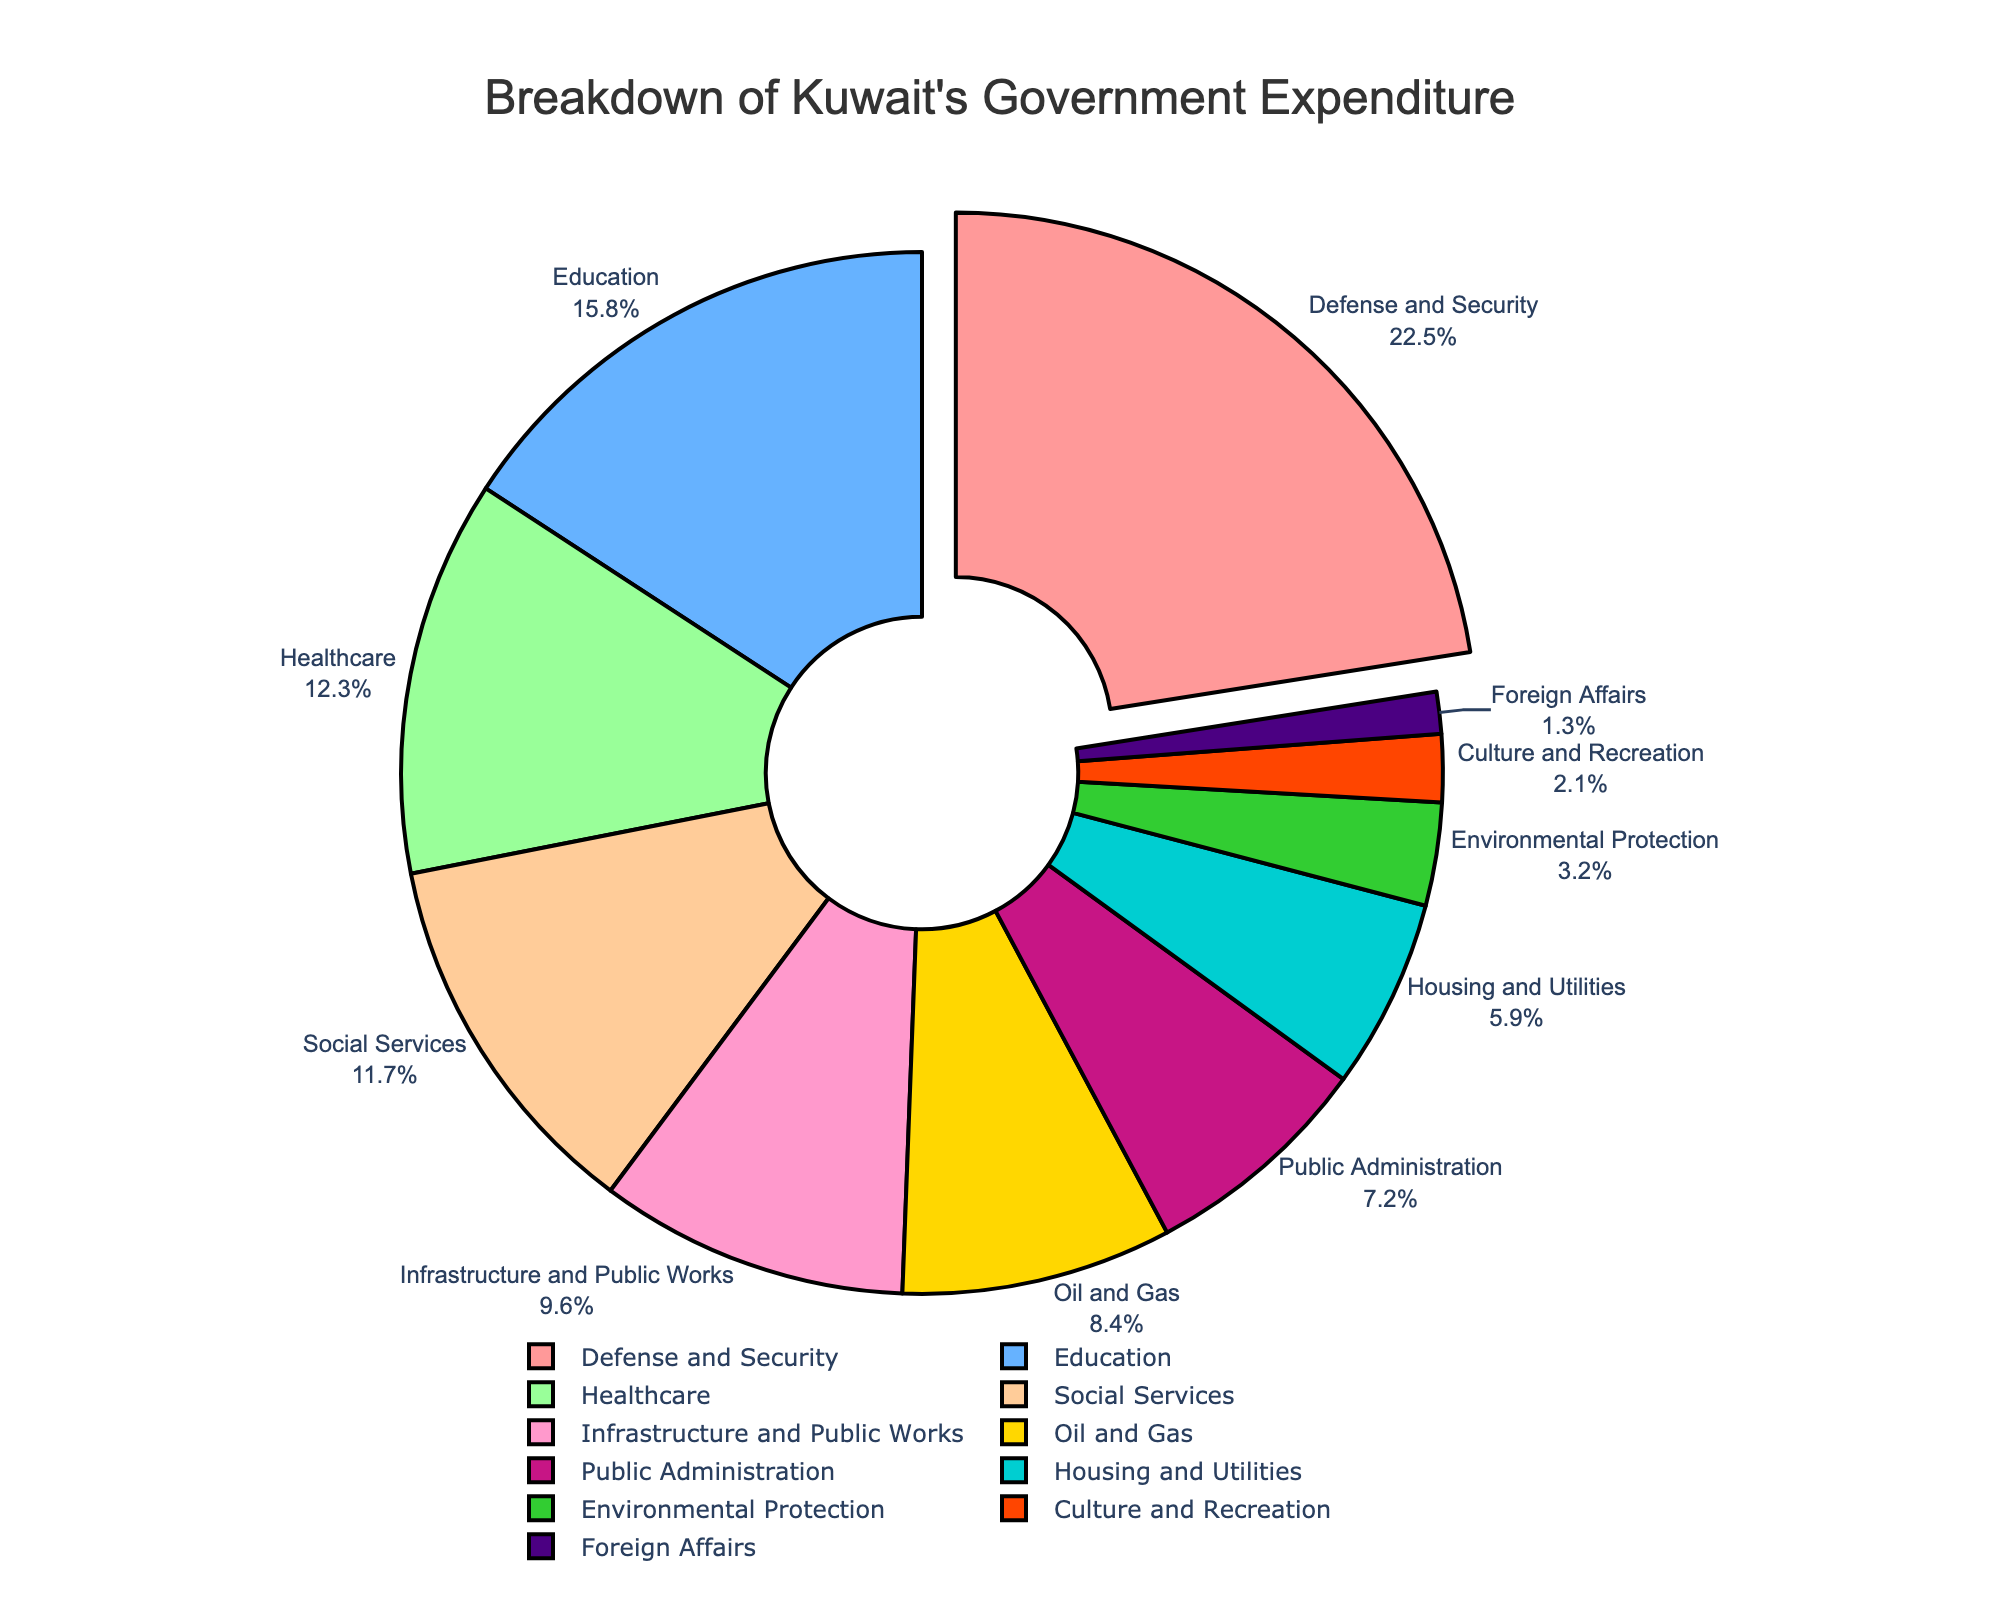Which sector receives the highest proportion of expenditure? The figure shows that the sector with the slice pulled out (defense and security) is the one with the highest expenditure, and the label indicates it is 22.5%.
Answer: Defense and Security What is the total percentage of expenditure for the Healthcare and Education sectors combined? Sum the percentage values for Healthcare (12.3%) and Education (15.8%). 12.3 + 15.8 = 28.1%
Answer: 28.1% How much more is spent on Defense and Security compared to Oil and Gas? Subtract the Oil and Gas percentage (8.4%) from the Defense and Security percentage (22.5%). 22.5 - 8.4 = 14.1%
Answer: 14.1% Which sector has the smallest proportion of government expenditure, and what is its percentage? Identify the smallest slice in the pie chart, which corresponds to Foreign Affairs, and note its percentage (1.3%).
Answer: Foreign Affairs, 1.3% Is the percentage of expenditure on Social Services higher or lower than on Infrastructure and Public Works? Compare the percentage values for Social Services (11.7%) and Infrastructure and Public Works (9.6%). Social Services has a higher percentage.
Answer: Higher Are the combined percentages for Housing and Utilities and Culture and Recreation greater than the percentage for Healthcare? Sum the percentages for Housing and Utilities (5.9%) and Culture and Recreation (2.1%). 5.9 + 2.1 = 8.0%. Compare with Healthcare (12.3%). 8.0% is less than 12.3%.
Answer: No What is the difference in expenditure percentage between the sectors of Public Administration and Housing and Utilities? Subtract the percentage for Housing and Utilities (5.9%) from Public Administration (7.2%). 7.2 - 5.9 = 1.3%
Answer: 1.3% Which sectors have a higher expenditure percentage than 10%? Identify sectors with percentages above 10%. These are Defense and Security (22.5%), Education (15.8%), Healthcare (12.3%), and Social Services (11.7%).
Answer: Defense and Security, Education, Healthcare, Social Services What is the visual color used to represent the Environmental Protection sector? Identify the color associated with Environmental Protection in the pie chart, which is often indicated distinctly. Environmental Protection is represented by a visual label in the chart.
Answer: Green 